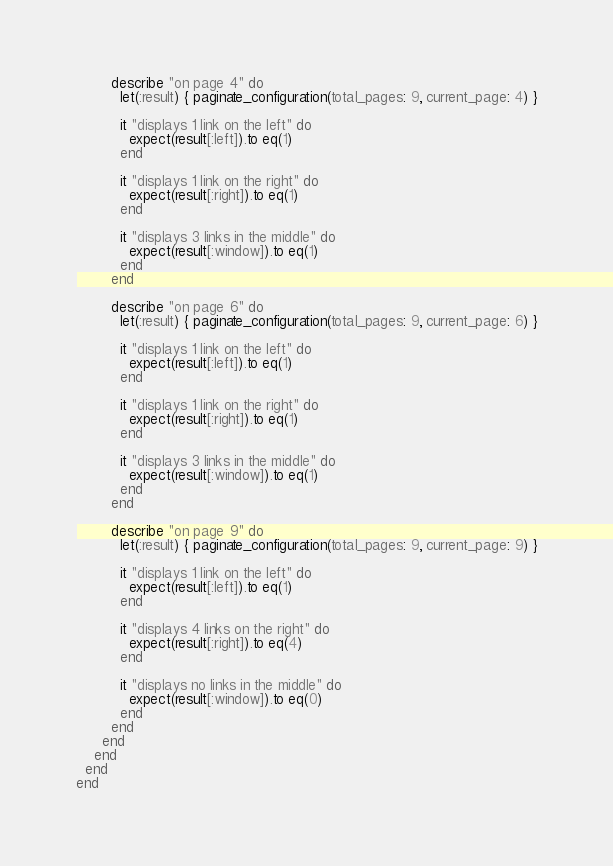Convert code to text. <code><loc_0><loc_0><loc_500><loc_500><_Ruby_>
        describe "on page 4" do
          let(:result) { paginate_configuration(total_pages: 9, current_page: 4) }

          it "displays 1 link on the left" do
            expect(result[:left]).to eq(1)
          end

          it "displays 1 link on the right" do
            expect(result[:right]).to eq(1)
          end

          it "displays 3 links in the middle" do
            expect(result[:window]).to eq(1)
          end
        end

        describe "on page 6" do
          let(:result) { paginate_configuration(total_pages: 9, current_page: 6) }

          it "displays 1 link on the left" do
            expect(result[:left]).to eq(1)
          end

          it "displays 1 link on the right" do
            expect(result[:right]).to eq(1)
          end

          it "displays 3 links in the middle" do
            expect(result[:window]).to eq(1)
          end
        end

        describe "on page 9" do
          let(:result) { paginate_configuration(total_pages: 9, current_page: 9) }

          it "displays 1 link on the left" do
            expect(result[:left]).to eq(1)
          end

          it "displays 4 links on the right" do
            expect(result[:right]).to eq(4)
          end

          it "displays no links in the middle" do
            expect(result[:window]).to eq(0)
          end
        end
      end
    end
  end
end
</code> 